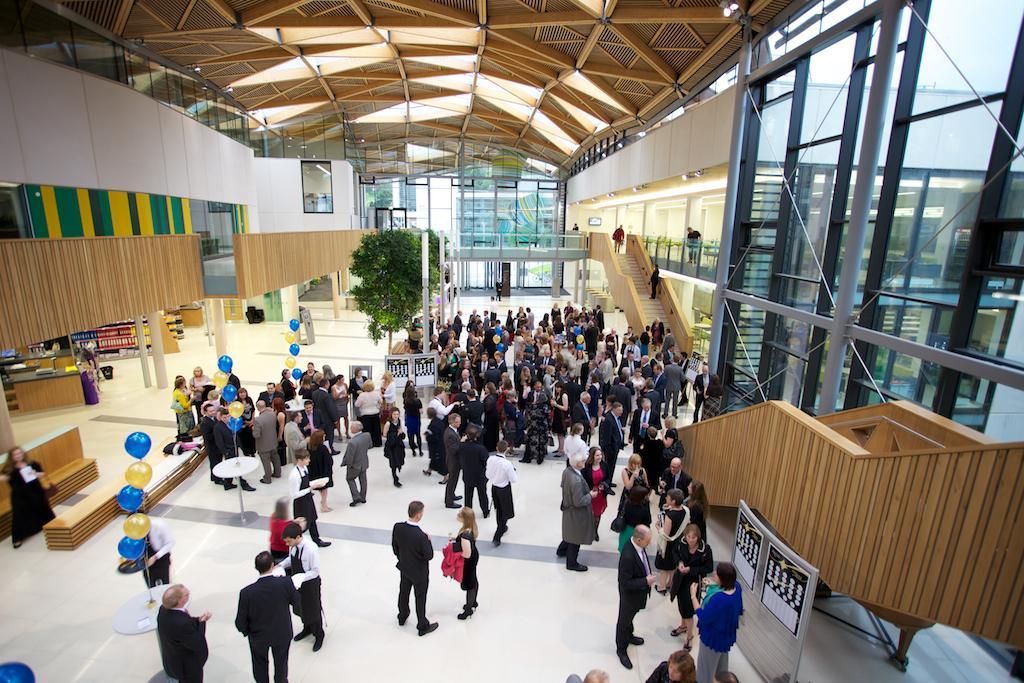In one or two sentences, can you explain what this image depicts? In this image I can see the floor, number of persons standing on the floor, few balloons which are blue and yellow in color, the stairs, the railing, the wall, the ceiling, few lights and the glass windows through which I can see another building and the sky. 